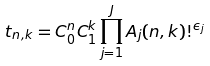Convert formula to latex. <formula><loc_0><loc_0><loc_500><loc_500>t _ { n , k } = C _ { 0 } ^ { n } C _ { 1 } ^ { k } \prod _ { j = 1 } ^ { J } A _ { j } ( n , k ) ! ^ { \epsilon _ { j } }</formula> 